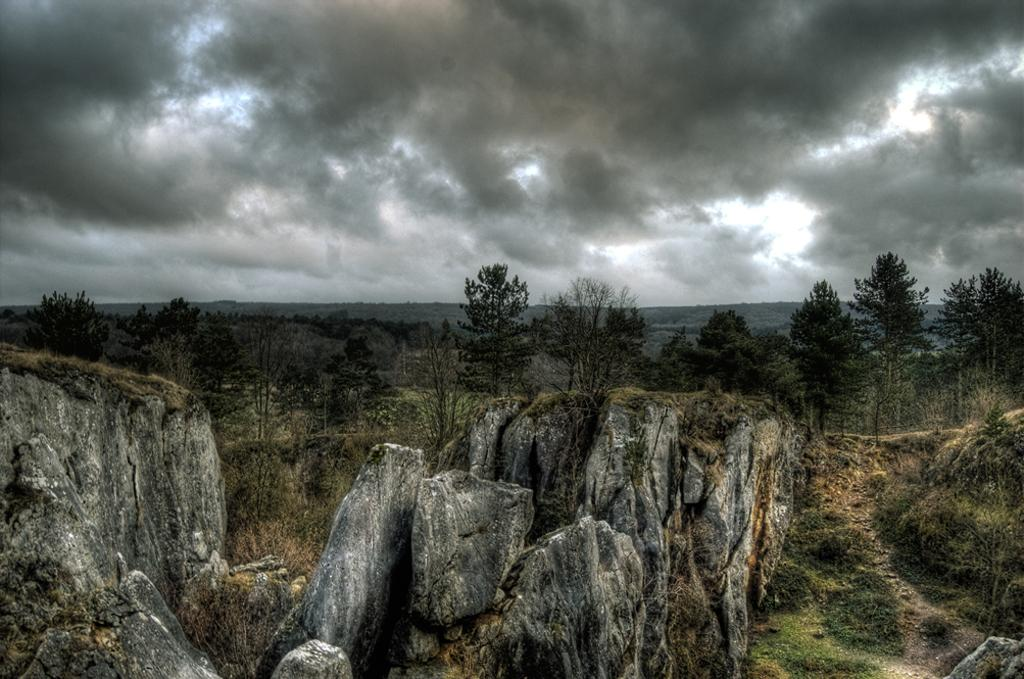What type of natural elements can be seen in the image? There are rocks, trees with branches and leaves, and grass visible in the image. What is the condition of the sky in the image? There are clouds in the sky in the image. What type of crime is being committed in the image? There is no indication of any crime being committed in the image, as it features natural elements such as rocks, trees, grass, and clouds. Who is the friend that can be seen in the image? There is no person or friend present in the image; it only contains natural elements. 